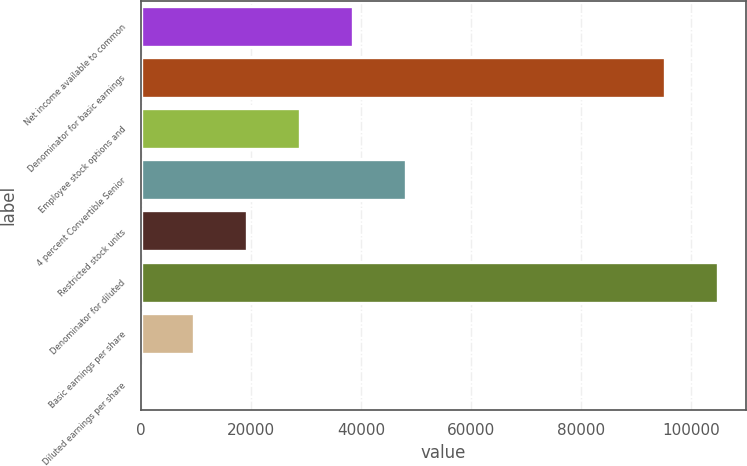Convert chart. <chart><loc_0><loc_0><loc_500><loc_500><bar_chart><fcel>Net income available to common<fcel>Denominator for basic earnings<fcel>Employee stock options and<fcel>4 percent Convertible Senior<fcel>Restricted stock units<fcel>Denominator for diluted<fcel>Basic earnings per share<fcel>Diluted earnings per share<nl><fcel>38555.2<fcel>95170<fcel>28917.9<fcel>48192.5<fcel>19280.7<fcel>104807<fcel>9643.36<fcel>6.07<nl></chart> 